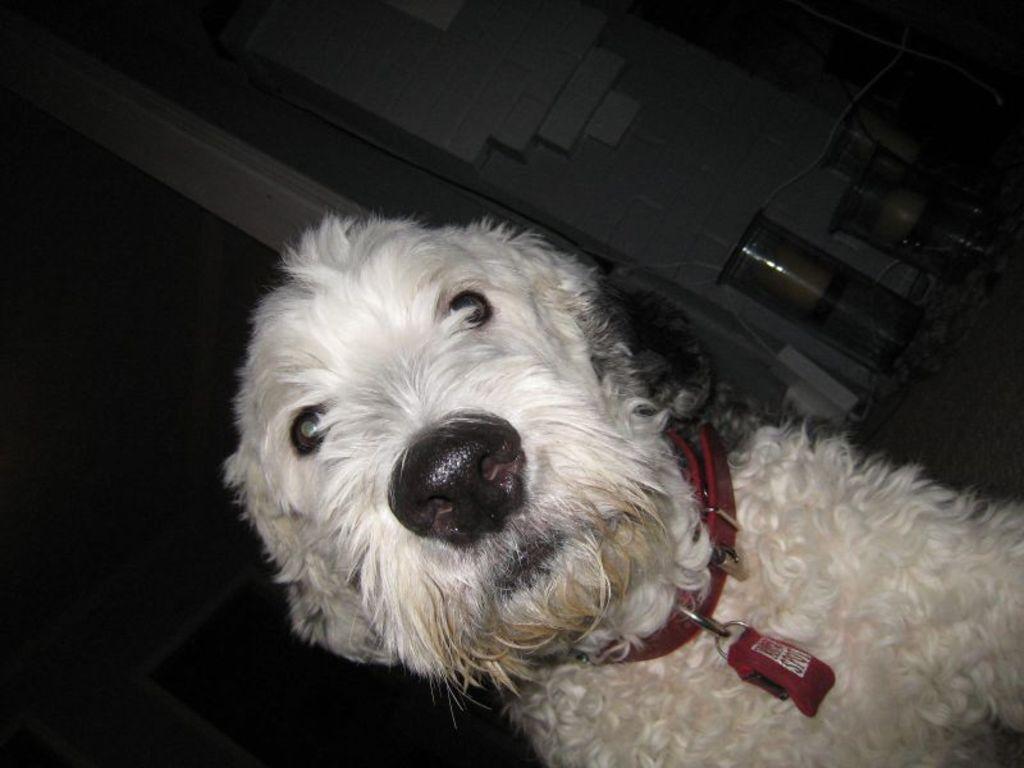Please provide a concise description of this image. In this image I can see the dog in white color. In the background I can see few objects and the wall is in cream and white color. 